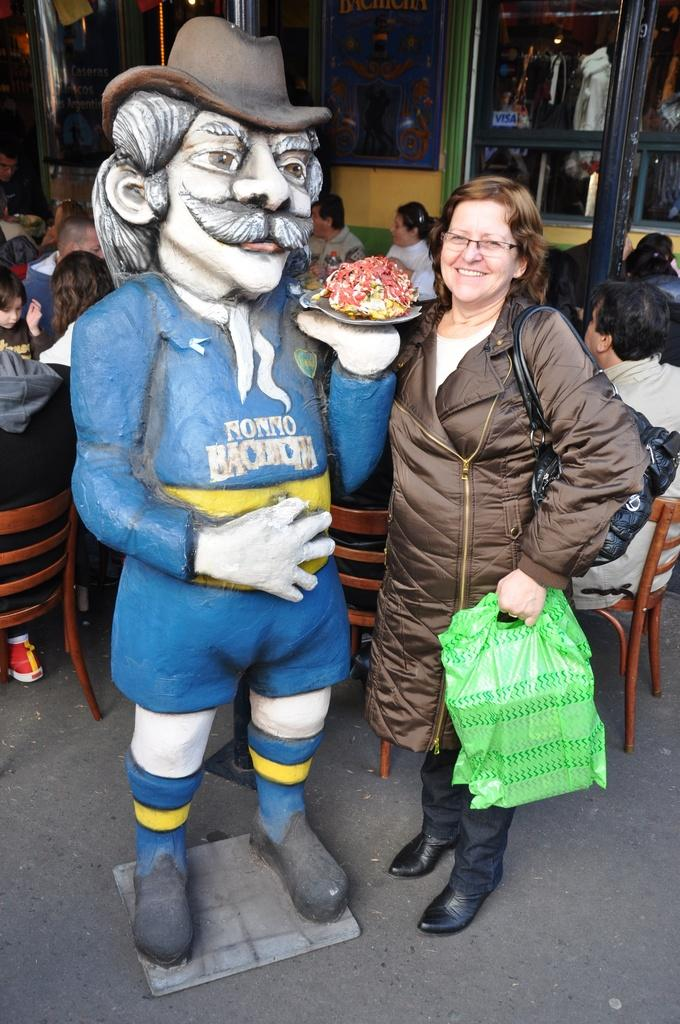What is the lady holding in the image? The lady is holding a polythene in the image. What is the lady standing beside? The lady is standing beside a statue. What can be seen in the image involving people and a table? There are people sitting around a table in the image. What can be seen in the background of the image? There are windows visible in the background of the image. What type of frame is the kitten sitting in on the table? There is no kitten present in the image, and therefore no frame or table for the kitten to sit in. 